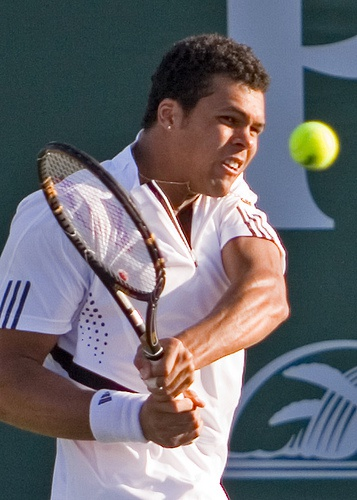Describe the objects in this image and their specific colors. I can see people in black, darkgray, lightgray, and maroon tones, tennis racket in black, darkgray, lightgray, and gray tones, and sports ball in black, olive, khaki, and lightyellow tones in this image. 